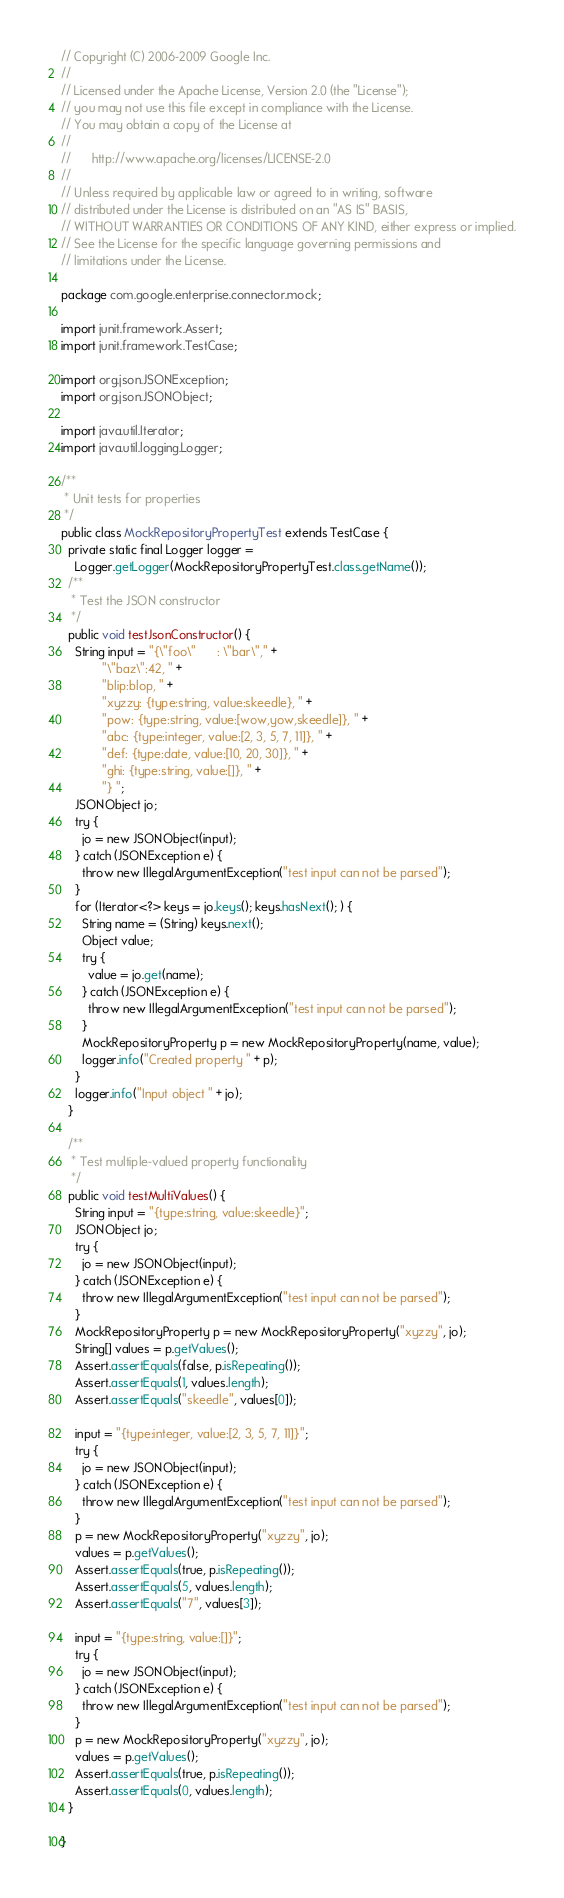Convert code to text. <code><loc_0><loc_0><loc_500><loc_500><_Java_>// Copyright (C) 2006-2009 Google Inc.
//
// Licensed under the Apache License, Version 2.0 (the "License");
// you may not use this file except in compliance with the License.
// You may obtain a copy of the License at
//
//      http://www.apache.org/licenses/LICENSE-2.0
//
// Unless required by applicable law or agreed to in writing, software
// distributed under the License is distributed on an "AS IS" BASIS,
// WITHOUT WARRANTIES OR CONDITIONS OF ANY KIND, either express or implied.
// See the License for the specific language governing permissions and
// limitations under the License.

package com.google.enterprise.connector.mock;

import junit.framework.Assert;
import junit.framework.TestCase;

import org.json.JSONException;
import org.json.JSONObject;

import java.util.Iterator;
import java.util.logging.Logger;

/**
 * Unit tests for properties
 */
public class MockRepositoryPropertyTest extends TestCase {
  private static final Logger logger =
    Logger.getLogger(MockRepositoryPropertyTest.class.getName());
  /**
   * Test the JSON constructor
   */
  public void testJsonConstructor() {
    String input = "{\"foo\"      : \"bar\"," +
            "\"baz\":42, " +
            "blip:blop, " +
            "xyzzy: {type:string, value:skeedle}, " +
            "pow: {type:string, value:[wow,yow,skeedle]}, " +
            "abc: {type:integer, value:[2, 3, 5, 7, 11]}, " +
            "def: {type:date, value:[10, 20, 30]}, " +
            "ghi: {type:string, value:[]}, " +
            "} ";
    JSONObject jo;
    try {
      jo = new JSONObject(input);
    } catch (JSONException e) {
      throw new IllegalArgumentException("test input can not be parsed");
    }
    for (Iterator<?> keys = jo.keys(); keys.hasNext(); ) {
      String name = (String) keys.next();
      Object value;
      try {
        value = jo.get(name);
      } catch (JSONException e) {
        throw new IllegalArgumentException("test input can not be parsed");
      }
      MockRepositoryProperty p = new MockRepositoryProperty(name, value);
      logger.info("Created property " + p);
    }
    logger.info("Input object " + jo);
  }

  /**
   * Test multiple-valued property functionality
   */
  public void testMultiValues() {
    String input = "{type:string, value:skeedle}";
    JSONObject jo;
    try {
      jo = new JSONObject(input);
    } catch (JSONException e) {
      throw new IllegalArgumentException("test input can not be parsed");
    }
    MockRepositoryProperty p = new MockRepositoryProperty("xyzzy", jo);
    String[] values = p.getValues();
    Assert.assertEquals(false, p.isRepeating());
    Assert.assertEquals(1, values.length);
    Assert.assertEquals("skeedle", values[0]);

    input = "{type:integer, value:[2, 3, 5, 7, 11]}";
    try {
      jo = new JSONObject(input);
    } catch (JSONException e) {
      throw new IllegalArgumentException("test input can not be parsed");
    }
    p = new MockRepositoryProperty("xyzzy", jo);
    values = p.getValues();
    Assert.assertEquals(true, p.isRepeating());
    Assert.assertEquals(5, values.length);
    Assert.assertEquals("7", values[3]);

    input = "{type:string, value:[]}";
    try {
      jo = new JSONObject(input);
    } catch (JSONException e) {
      throw new IllegalArgumentException("test input can not be parsed");
    }
    p = new MockRepositoryProperty("xyzzy", jo);
    values = p.getValues();
    Assert.assertEquals(true, p.isRepeating());
    Assert.assertEquals(0, values.length);
  }

}
</code> 